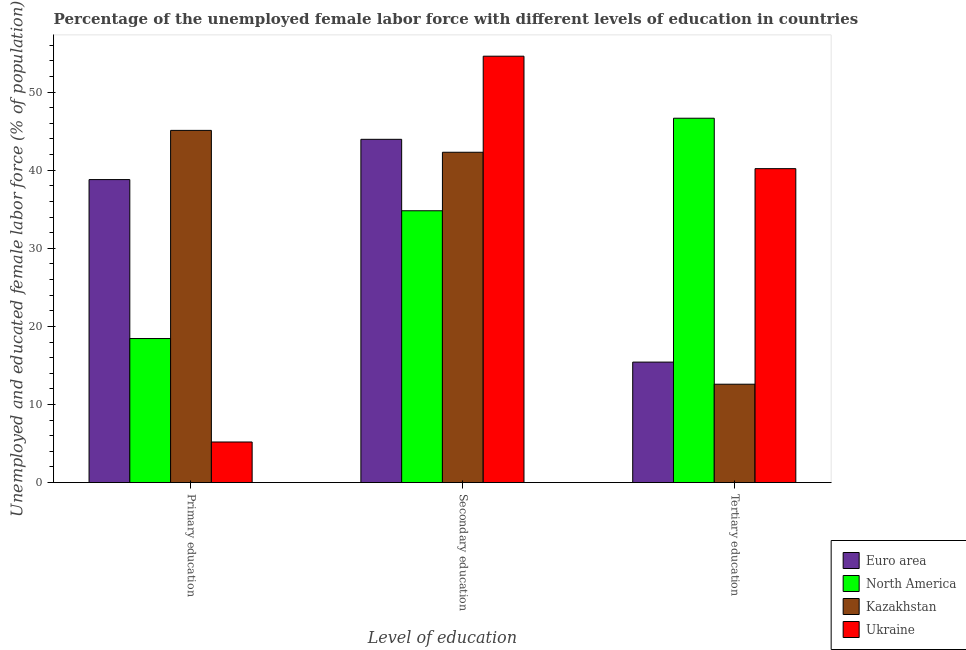How many different coloured bars are there?
Keep it short and to the point. 4. How many groups of bars are there?
Offer a very short reply. 3. Are the number of bars per tick equal to the number of legend labels?
Offer a very short reply. Yes. What is the label of the 2nd group of bars from the left?
Give a very brief answer. Secondary education. What is the percentage of female labor force who received primary education in Kazakhstan?
Offer a terse response. 45.1. Across all countries, what is the maximum percentage of female labor force who received tertiary education?
Your answer should be compact. 46.66. Across all countries, what is the minimum percentage of female labor force who received tertiary education?
Provide a succinct answer. 12.6. In which country was the percentage of female labor force who received secondary education minimum?
Give a very brief answer. North America. What is the total percentage of female labor force who received primary education in the graph?
Keep it short and to the point. 107.55. What is the difference between the percentage of female labor force who received secondary education in Euro area and that in Ukraine?
Offer a very short reply. -10.64. What is the difference between the percentage of female labor force who received primary education in Ukraine and the percentage of female labor force who received secondary education in Kazakhstan?
Your response must be concise. -37.1. What is the average percentage of female labor force who received primary education per country?
Ensure brevity in your answer.  26.89. What is the difference between the percentage of female labor force who received secondary education and percentage of female labor force who received primary education in Ukraine?
Keep it short and to the point. 49.4. What is the ratio of the percentage of female labor force who received secondary education in Ukraine to that in Euro area?
Keep it short and to the point. 1.24. Is the percentage of female labor force who received primary education in Kazakhstan less than that in Euro area?
Your answer should be compact. No. Is the difference between the percentage of female labor force who received primary education in Kazakhstan and North America greater than the difference between the percentage of female labor force who received tertiary education in Kazakhstan and North America?
Your answer should be compact. Yes. What is the difference between the highest and the second highest percentage of female labor force who received primary education?
Your response must be concise. 6.3. What is the difference between the highest and the lowest percentage of female labor force who received primary education?
Your answer should be very brief. 39.9. What does the 4th bar from the left in Primary education represents?
Offer a very short reply. Ukraine. What does the 2nd bar from the right in Primary education represents?
Provide a short and direct response. Kazakhstan. How many bars are there?
Keep it short and to the point. 12. Are all the bars in the graph horizontal?
Your answer should be compact. No. How many countries are there in the graph?
Offer a very short reply. 4. What is the difference between two consecutive major ticks on the Y-axis?
Your answer should be compact. 10. Are the values on the major ticks of Y-axis written in scientific E-notation?
Your response must be concise. No. Does the graph contain any zero values?
Give a very brief answer. No. Where does the legend appear in the graph?
Your answer should be compact. Bottom right. How are the legend labels stacked?
Give a very brief answer. Vertical. What is the title of the graph?
Give a very brief answer. Percentage of the unemployed female labor force with different levels of education in countries. Does "Belize" appear as one of the legend labels in the graph?
Offer a very short reply. No. What is the label or title of the X-axis?
Provide a succinct answer. Level of education. What is the label or title of the Y-axis?
Your answer should be very brief. Unemployed and educated female labor force (% of population). What is the Unemployed and educated female labor force (% of population) of Euro area in Primary education?
Offer a very short reply. 38.8. What is the Unemployed and educated female labor force (% of population) in North America in Primary education?
Ensure brevity in your answer.  18.45. What is the Unemployed and educated female labor force (% of population) of Kazakhstan in Primary education?
Provide a short and direct response. 45.1. What is the Unemployed and educated female labor force (% of population) in Ukraine in Primary education?
Keep it short and to the point. 5.2. What is the Unemployed and educated female labor force (% of population) in Euro area in Secondary education?
Keep it short and to the point. 43.96. What is the Unemployed and educated female labor force (% of population) in North America in Secondary education?
Provide a short and direct response. 34.81. What is the Unemployed and educated female labor force (% of population) of Kazakhstan in Secondary education?
Your answer should be very brief. 42.3. What is the Unemployed and educated female labor force (% of population) of Ukraine in Secondary education?
Make the answer very short. 54.6. What is the Unemployed and educated female labor force (% of population) in Euro area in Tertiary education?
Your answer should be very brief. 15.43. What is the Unemployed and educated female labor force (% of population) of North America in Tertiary education?
Give a very brief answer. 46.66. What is the Unemployed and educated female labor force (% of population) in Kazakhstan in Tertiary education?
Give a very brief answer. 12.6. What is the Unemployed and educated female labor force (% of population) of Ukraine in Tertiary education?
Your response must be concise. 40.2. Across all Level of education, what is the maximum Unemployed and educated female labor force (% of population) of Euro area?
Provide a short and direct response. 43.96. Across all Level of education, what is the maximum Unemployed and educated female labor force (% of population) in North America?
Ensure brevity in your answer.  46.66. Across all Level of education, what is the maximum Unemployed and educated female labor force (% of population) of Kazakhstan?
Offer a very short reply. 45.1. Across all Level of education, what is the maximum Unemployed and educated female labor force (% of population) in Ukraine?
Your response must be concise. 54.6. Across all Level of education, what is the minimum Unemployed and educated female labor force (% of population) of Euro area?
Keep it short and to the point. 15.43. Across all Level of education, what is the minimum Unemployed and educated female labor force (% of population) of North America?
Provide a short and direct response. 18.45. Across all Level of education, what is the minimum Unemployed and educated female labor force (% of population) in Kazakhstan?
Offer a terse response. 12.6. Across all Level of education, what is the minimum Unemployed and educated female labor force (% of population) of Ukraine?
Offer a terse response. 5.2. What is the total Unemployed and educated female labor force (% of population) in Euro area in the graph?
Your answer should be very brief. 98.19. What is the total Unemployed and educated female labor force (% of population) of North America in the graph?
Keep it short and to the point. 99.91. What is the difference between the Unemployed and educated female labor force (% of population) of Euro area in Primary education and that in Secondary education?
Keep it short and to the point. -5.16. What is the difference between the Unemployed and educated female labor force (% of population) in North America in Primary education and that in Secondary education?
Offer a very short reply. -16.36. What is the difference between the Unemployed and educated female labor force (% of population) of Ukraine in Primary education and that in Secondary education?
Give a very brief answer. -49.4. What is the difference between the Unemployed and educated female labor force (% of population) in Euro area in Primary education and that in Tertiary education?
Your response must be concise. 23.37. What is the difference between the Unemployed and educated female labor force (% of population) of North America in Primary education and that in Tertiary education?
Offer a very short reply. -28.21. What is the difference between the Unemployed and educated female labor force (% of population) in Kazakhstan in Primary education and that in Tertiary education?
Make the answer very short. 32.5. What is the difference between the Unemployed and educated female labor force (% of population) in Ukraine in Primary education and that in Tertiary education?
Ensure brevity in your answer.  -35. What is the difference between the Unemployed and educated female labor force (% of population) in Euro area in Secondary education and that in Tertiary education?
Offer a very short reply. 28.53. What is the difference between the Unemployed and educated female labor force (% of population) of North America in Secondary education and that in Tertiary education?
Give a very brief answer. -11.85. What is the difference between the Unemployed and educated female labor force (% of population) in Kazakhstan in Secondary education and that in Tertiary education?
Provide a short and direct response. 29.7. What is the difference between the Unemployed and educated female labor force (% of population) of Euro area in Primary education and the Unemployed and educated female labor force (% of population) of North America in Secondary education?
Provide a short and direct response. 3.99. What is the difference between the Unemployed and educated female labor force (% of population) of Euro area in Primary education and the Unemployed and educated female labor force (% of population) of Kazakhstan in Secondary education?
Keep it short and to the point. -3.5. What is the difference between the Unemployed and educated female labor force (% of population) of Euro area in Primary education and the Unemployed and educated female labor force (% of population) of Ukraine in Secondary education?
Your response must be concise. -15.8. What is the difference between the Unemployed and educated female labor force (% of population) in North America in Primary education and the Unemployed and educated female labor force (% of population) in Kazakhstan in Secondary education?
Make the answer very short. -23.85. What is the difference between the Unemployed and educated female labor force (% of population) of North America in Primary education and the Unemployed and educated female labor force (% of population) of Ukraine in Secondary education?
Your response must be concise. -36.15. What is the difference between the Unemployed and educated female labor force (% of population) in Euro area in Primary education and the Unemployed and educated female labor force (% of population) in North America in Tertiary education?
Offer a terse response. -7.86. What is the difference between the Unemployed and educated female labor force (% of population) of Euro area in Primary education and the Unemployed and educated female labor force (% of population) of Kazakhstan in Tertiary education?
Ensure brevity in your answer.  26.2. What is the difference between the Unemployed and educated female labor force (% of population) in Euro area in Primary education and the Unemployed and educated female labor force (% of population) in Ukraine in Tertiary education?
Keep it short and to the point. -1.4. What is the difference between the Unemployed and educated female labor force (% of population) of North America in Primary education and the Unemployed and educated female labor force (% of population) of Kazakhstan in Tertiary education?
Ensure brevity in your answer.  5.85. What is the difference between the Unemployed and educated female labor force (% of population) of North America in Primary education and the Unemployed and educated female labor force (% of population) of Ukraine in Tertiary education?
Your answer should be very brief. -21.75. What is the difference between the Unemployed and educated female labor force (% of population) of Euro area in Secondary education and the Unemployed and educated female labor force (% of population) of North America in Tertiary education?
Offer a very short reply. -2.7. What is the difference between the Unemployed and educated female labor force (% of population) of Euro area in Secondary education and the Unemployed and educated female labor force (% of population) of Kazakhstan in Tertiary education?
Your answer should be compact. 31.36. What is the difference between the Unemployed and educated female labor force (% of population) of Euro area in Secondary education and the Unemployed and educated female labor force (% of population) of Ukraine in Tertiary education?
Make the answer very short. 3.76. What is the difference between the Unemployed and educated female labor force (% of population) in North America in Secondary education and the Unemployed and educated female labor force (% of population) in Kazakhstan in Tertiary education?
Offer a very short reply. 22.21. What is the difference between the Unemployed and educated female labor force (% of population) of North America in Secondary education and the Unemployed and educated female labor force (% of population) of Ukraine in Tertiary education?
Offer a very short reply. -5.39. What is the average Unemployed and educated female labor force (% of population) in Euro area per Level of education?
Your answer should be very brief. 32.73. What is the average Unemployed and educated female labor force (% of population) in North America per Level of education?
Make the answer very short. 33.3. What is the average Unemployed and educated female labor force (% of population) in Kazakhstan per Level of education?
Your response must be concise. 33.33. What is the average Unemployed and educated female labor force (% of population) in Ukraine per Level of education?
Ensure brevity in your answer.  33.33. What is the difference between the Unemployed and educated female labor force (% of population) of Euro area and Unemployed and educated female labor force (% of population) of North America in Primary education?
Make the answer very short. 20.35. What is the difference between the Unemployed and educated female labor force (% of population) in Euro area and Unemployed and educated female labor force (% of population) in Kazakhstan in Primary education?
Keep it short and to the point. -6.3. What is the difference between the Unemployed and educated female labor force (% of population) in Euro area and Unemployed and educated female labor force (% of population) in Ukraine in Primary education?
Make the answer very short. 33.6. What is the difference between the Unemployed and educated female labor force (% of population) of North America and Unemployed and educated female labor force (% of population) of Kazakhstan in Primary education?
Provide a succinct answer. -26.65. What is the difference between the Unemployed and educated female labor force (% of population) in North America and Unemployed and educated female labor force (% of population) in Ukraine in Primary education?
Ensure brevity in your answer.  13.25. What is the difference between the Unemployed and educated female labor force (% of population) in Kazakhstan and Unemployed and educated female labor force (% of population) in Ukraine in Primary education?
Provide a short and direct response. 39.9. What is the difference between the Unemployed and educated female labor force (% of population) of Euro area and Unemployed and educated female labor force (% of population) of North America in Secondary education?
Offer a very short reply. 9.15. What is the difference between the Unemployed and educated female labor force (% of population) of Euro area and Unemployed and educated female labor force (% of population) of Kazakhstan in Secondary education?
Your answer should be very brief. 1.66. What is the difference between the Unemployed and educated female labor force (% of population) in Euro area and Unemployed and educated female labor force (% of population) in Ukraine in Secondary education?
Provide a short and direct response. -10.64. What is the difference between the Unemployed and educated female labor force (% of population) in North America and Unemployed and educated female labor force (% of population) in Kazakhstan in Secondary education?
Your response must be concise. -7.49. What is the difference between the Unemployed and educated female labor force (% of population) of North America and Unemployed and educated female labor force (% of population) of Ukraine in Secondary education?
Your response must be concise. -19.79. What is the difference between the Unemployed and educated female labor force (% of population) of Kazakhstan and Unemployed and educated female labor force (% of population) of Ukraine in Secondary education?
Make the answer very short. -12.3. What is the difference between the Unemployed and educated female labor force (% of population) of Euro area and Unemployed and educated female labor force (% of population) of North America in Tertiary education?
Make the answer very short. -31.23. What is the difference between the Unemployed and educated female labor force (% of population) in Euro area and Unemployed and educated female labor force (% of population) in Kazakhstan in Tertiary education?
Your answer should be compact. 2.83. What is the difference between the Unemployed and educated female labor force (% of population) in Euro area and Unemployed and educated female labor force (% of population) in Ukraine in Tertiary education?
Your answer should be very brief. -24.77. What is the difference between the Unemployed and educated female labor force (% of population) in North America and Unemployed and educated female labor force (% of population) in Kazakhstan in Tertiary education?
Your answer should be very brief. 34.06. What is the difference between the Unemployed and educated female labor force (% of population) in North America and Unemployed and educated female labor force (% of population) in Ukraine in Tertiary education?
Provide a short and direct response. 6.46. What is the difference between the Unemployed and educated female labor force (% of population) of Kazakhstan and Unemployed and educated female labor force (% of population) of Ukraine in Tertiary education?
Make the answer very short. -27.6. What is the ratio of the Unemployed and educated female labor force (% of population) in Euro area in Primary education to that in Secondary education?
Your response must be concise. 0.88. What is the ratio of the Unemployed and educated female labor force (% of population) in North America in Primary education to that in Secondary education?
Provide a succinct answer. 0.53. What is the ratio of the Unemployed and educated female labor force (% of population) in Kazakhstan in Primary education to that in Secondary education?
Give a very brief answer. 1.07. What is the ratio of the Unemployed and educated female labor force (% of population) of Ukraine in Primary education to that in Secondary education?
Provide a short and direct response. 0.1. What is the ratio of the Unemployed and educated female labor force (% of population) of Euro area in Primary education to that in Tertiary education?
Your response must be concise. 2.51. What is the ratio of the Unemployed and educated female labor force (% of population) in North America in Primary education to that in Tertiary education?
Keep it short and to the point. 0.4. What is the ratio of the Unemployed and educated female labor force (% of population) in Kazakhstan in Primary education to that in Tertiary education?
Your answer should be very brief. 3.58. What is the ratio of the Unemployed and educated female labor force (% of population) in Ukraine in Primary education to that in Tertiary education?
Provide a short and direct response. 0.13. What is the ratio of the Unemployed and educated female labor force (% of population) of Euro area in Secondary education to that in Tertiary education?
Ensure brevity in your answer.  2.85. What is the ratio of the Unemployed and educated female labor force (% of population) in North America in Secondary education to that in Tertiary education?
Provide a short and direct response. 0.75. What is the ratio of the Unemployed and educated female labor force (% of population) of Kazakhstan in Secondary education to that in Tertiary education?
Make the answer very short. 3.36. What is the ratio of the Unemployed and educated female labor force (% of population) of Ukraine in Secondary education to that in Tertiary education?
Offer a very short reply. 1.36. What is the difference between the highest and the second highest Unemployed and educated female labor force (% of population) of Euro area?
Your response must be concise. 5.16. What is the difference between the highest and the second highest Unemployed and educated female labor force (% of population) in North America?
Make the answer very short. 11.85. What is the difference between the highest and the second highest Unemployed and educated female labor force (% of population) in Kazakhstan?
Keep it short and to the point. 2.8. What is the difference between the highest and the lowest Unemployed and educated female labor force (% of population) in Euro area?
Your answer should be compact. 28.53. What is the difference between the highest and the lowest Unemployed and educated female labor force (% of population) of North America?
Your answer should be very brief. 28.21. What is the difference between the highest and the lowest Unemployed and educated female labor force (% of population) of Kazakhstan?
Provide a succinct answer. 32.5. What is the difference between the highest and the lowest Unemployed and educated female labor force (% of population) in Ukraine?
Offer a terse response. 49.4. 